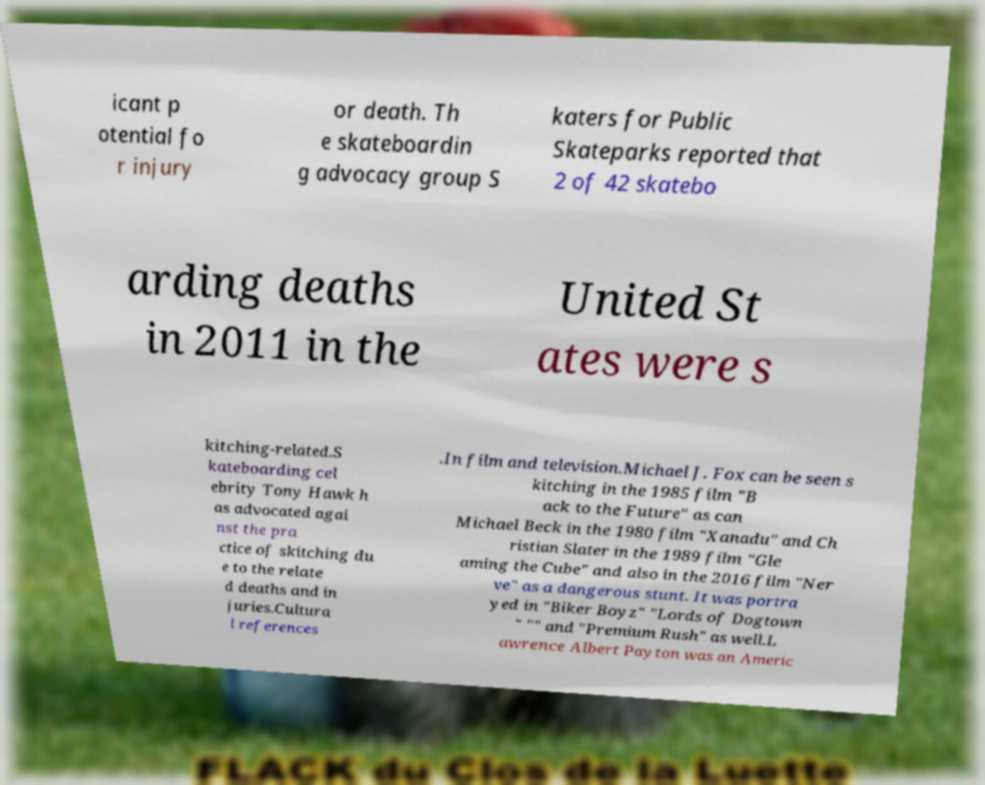What messages or text are displayed in this image? I need them in a readable, typed format. icant p otential fo r injury or death. Th e skateboardin g advocacy group S katers for Public Skateparks reported that 2 of 42 skatebo arding deaths in 2011 in the United St ates were s kitching-related.S kateboarding cel ebrity Tony Hawk h as advocated agai nst the pra ctice of skitching du e to the relate d deaths and in juries.Cultura l references .In film and television.Michael J. Fox can be seen s kitching in the 1985 film "B ack to the Future" as can Michael Beck in the 1980 film "Xanadu" and Ch ristian Slater in the 1989 film "Gle aming the Cube" and also in the 2016 film "Ner ve" as a dangerous stunt. It was portra yed in "Biker Boyz" "Lords of Dogtown " "" and "Premium Rush" as well.L awrence Albert Payton was an Americ 